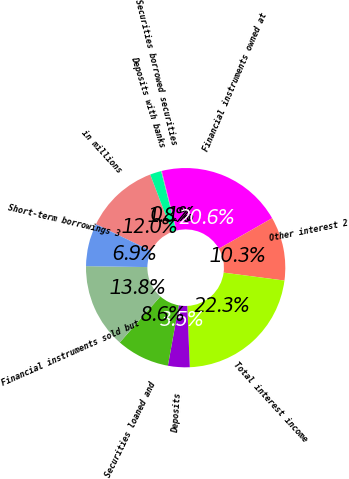<chart> <loc_0><loc_0><loc_500><loc_500><pie_chart><fcel>in millions<fcel>Deposits with banks<fcel>Securities borrowed securities<fcel>Financial instruments owned at<fcel>Other interest 2<fcel>Total interest income<fcel>Deposits<fcel>Securities loaned and<fcel>Financial instruments sold but<fcel>Short-term borrowings 3<nl><fcel>12.04%<fcel>1.82%<fcel>0.12%<fcel>20.57%<fcel>10.34%<fcel>22.27%<fcel>3.52%<fcel>8.64%<fcel>13.75%<fcel>6.93%<nl></chart> 